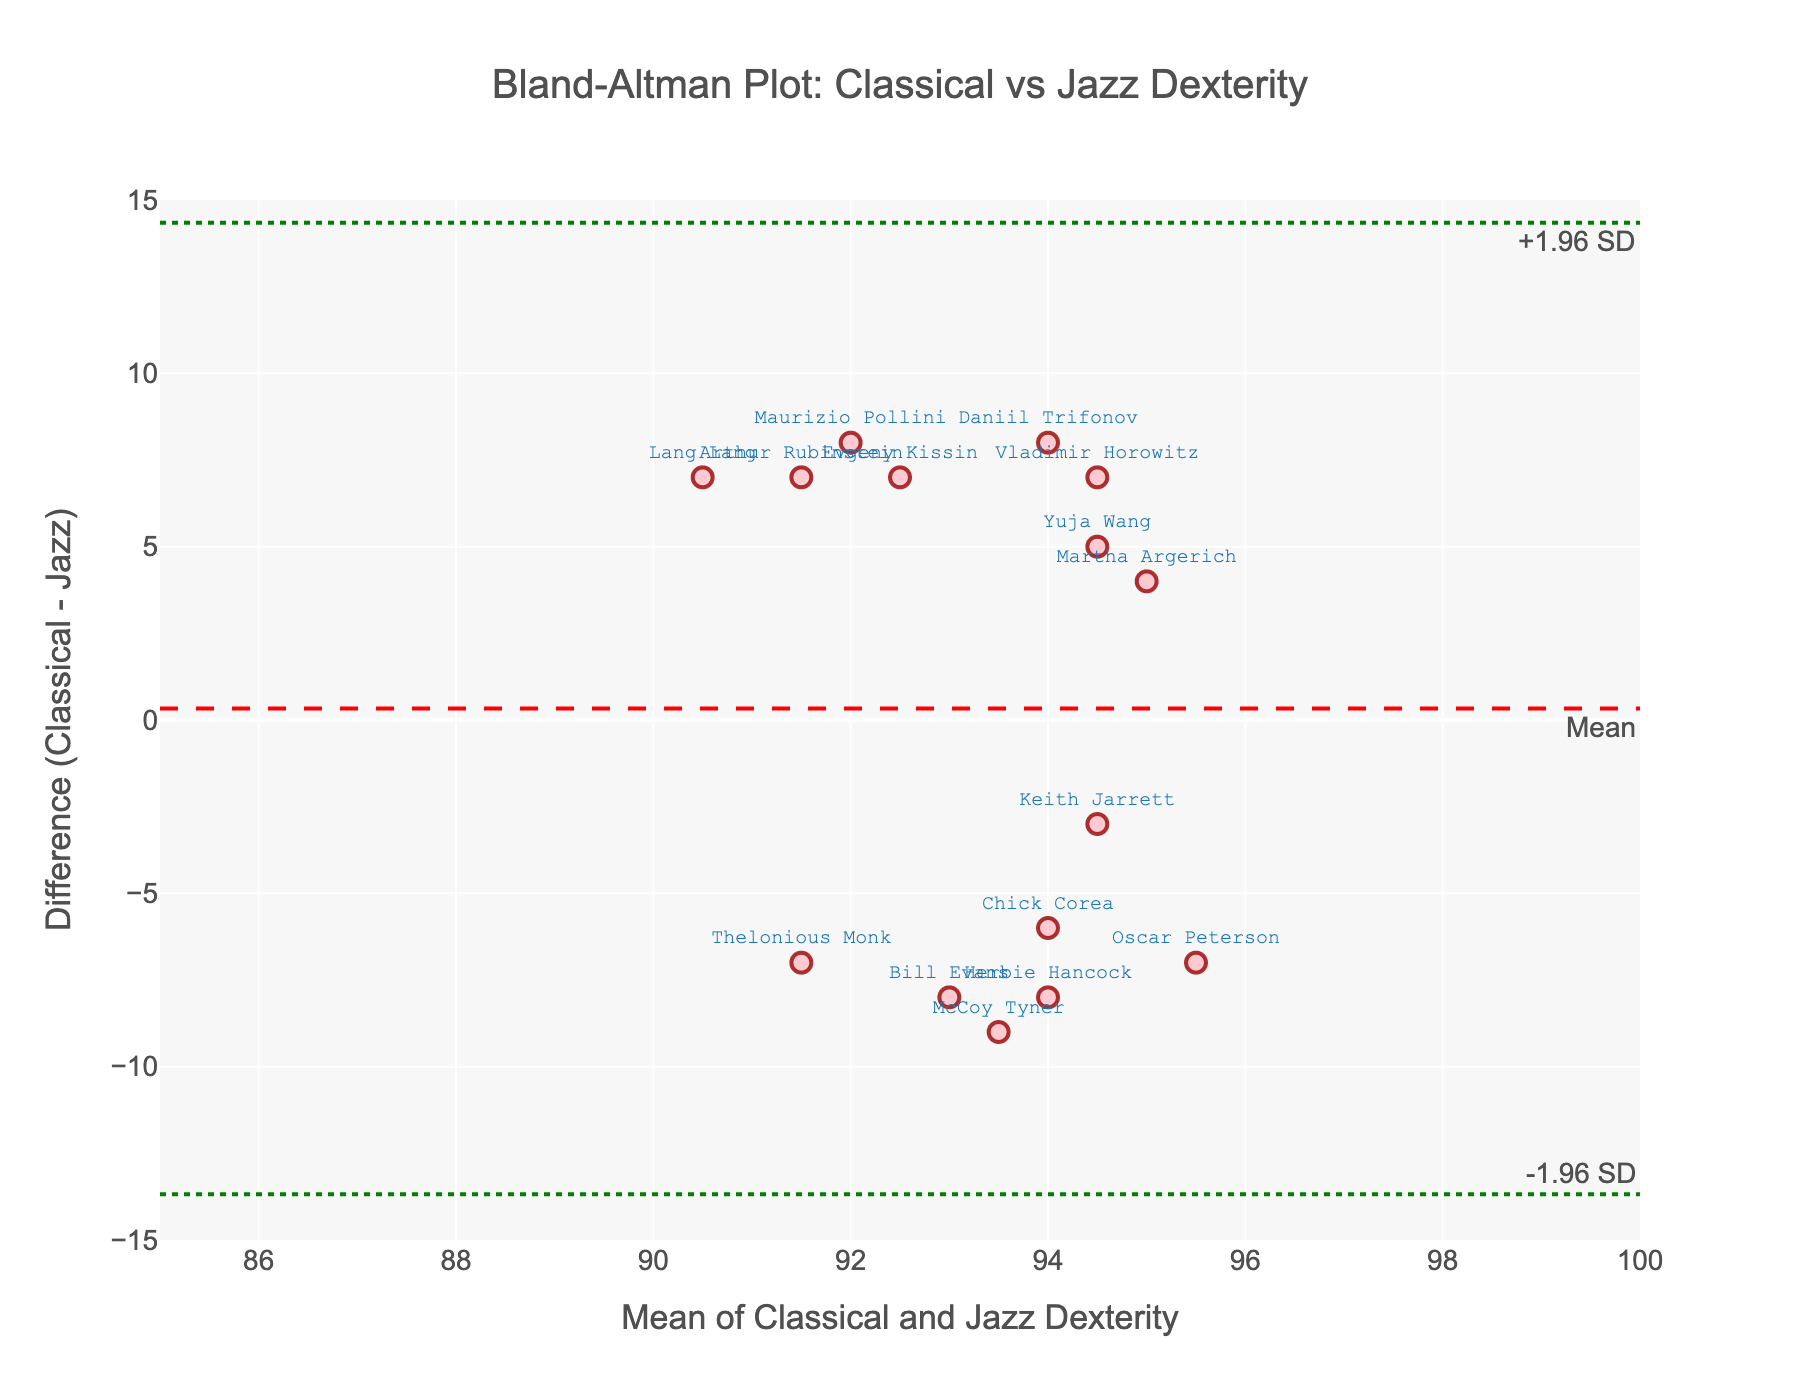what is the title of the plot? Look at the top of the figure, the title is clearly indicated there.
Answer: Bland-Altman Plot: Classical vs Jazz Dexterity what does the x-axis represent? The x-axis label is shown below the horizontal axis in the figure, describing what it represents.
Answer: Mean of Classical and Jazz Dexterity how many data points are present in the figure? Count the number of markers or points present in the scatter plot.
Answer: 15 which pianist has the highest difference in dexterity, and what is the value? Identify the point that is furthest vertically from the zero line and refer to its label to find the corresponding pianist.
Answer: Lang Lang, -7 what is the mean difference shown in the plot? The mean difference is indicated by the dashed red horizontal line, and the value is labeled near it.
Answer: Around -5.27 which pianist has the lowest mean dexterity, and what is the value? The mean dexterity is represented along the x-axis, find the point with the lowest x-coordinate and refer to its label.
Answer: Thelonious Monk, 91.5 are there more pianists with positive differences or negative differences in dexterity? Count the number of points above and below the zero line on the y-axis and compare the two counts.
Answer: More negative differences which two pianists have the closest mean dexterity, and what is their value? Identify two points that are closest horizontally and refer to their labels to find the corresponding pianists and their x-coordinate.
Answer: Keith Jarrett and Chick Corea, 94.5 are the majority of the points within the ±1.96 SD range? Observe the number of points that fall within the green dotted lines and compare it to the total number of points.
Answer: Yes which pianist has the smallest absolute difference in dexterity, and what is the value? Identify the point closest to the zero line on the y-axis and refer to its label, then state its y-coordinate.
Answer: Keith Jarrett, -3 